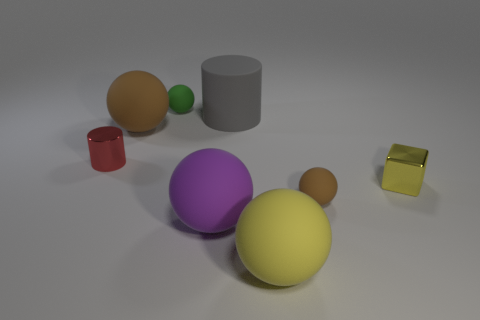Subtract all yellow balls. How many balls are left? 4 Subtract all yellow rubber spheres. How many spheres are left? 4 Subtract all cyan spheres. Subtract all brown cubes. How many spheres are left? 5 Add 1 metal blocks. How many objects exist? 9 Subtract all balls. How many objects are left? 3 Subtract 0 gray blocks. How many objects are left? 8 Subtract all large yellow balls. Subtract all green things. How many objects are left? 6 Add 1 small yellow blocks. How many small yellow blocks are left? 2 Add 4 yellow blocks. How many yellow blocks exist? 5 